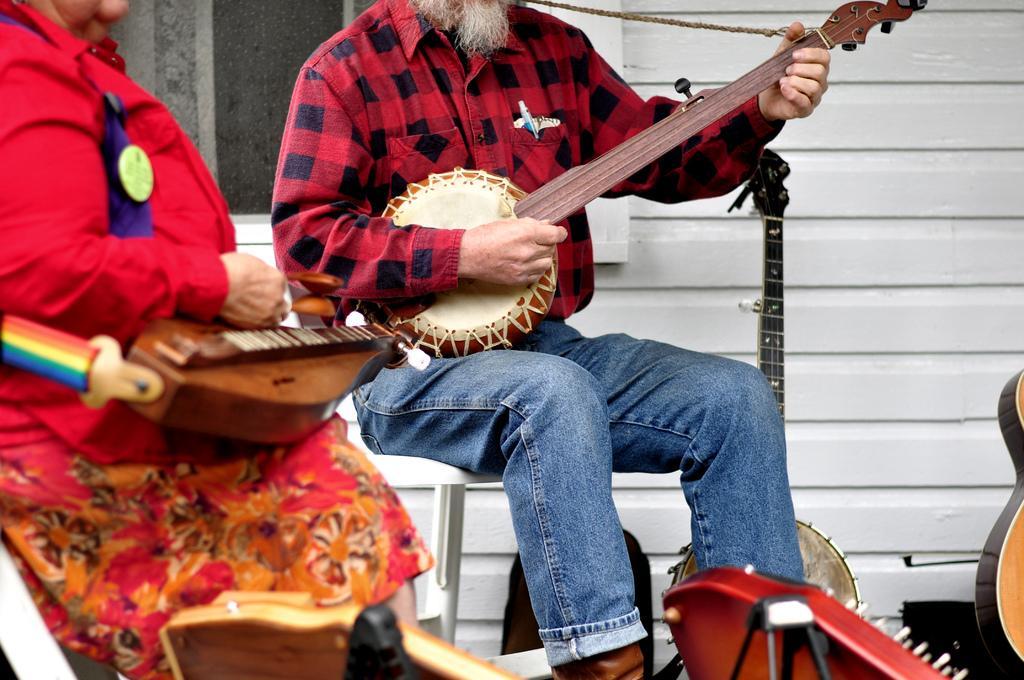Could you give a brief overview of what you see in this image? In this image there are two persons who are playing musical instruments at the middle of the image there is a person wearing red color dress playing guitar and at the left side of the image a lady person wearing red color also playing the musical instrument. 